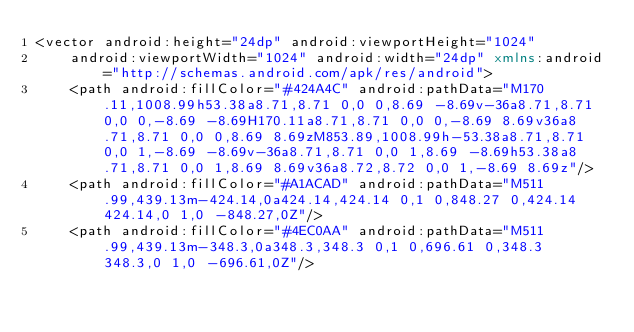Convert code to text. <code><loc_0><loc_0><loc_500><loc_500><_XML_><vector android:height="24dp" android:viewportHeight="1024"
    android:viewportWidth="1024" android:width="24dp" xmlns:android="http://schemas.android.com/apk/res/android">
    <path android:fillColor="#424A4C" android:pathData="M170.11,1008.99h53.38a8.71,8.71 0,0 0,8.69 -8.69v-36a8.71,8.71 0,0 0,-8.69 -8.69H170.11a8.71,8.71 0,0 0,-8.69 8.69v36a8.71,8.71 0,0 0,8.69 8.69zM853.89,1008.99h-53.38a8.71,8.71 0,0 1,-8.69 -8.69v-36a8.71,8.71 0,0 1,8.69 -8.69h53.38a8.71,8.71 0,0 1,8.69 8.69v36a8.72,8.72 0,0 1,-8.69 8.69z"/>
    <path android:fillColor="#A1ACAD" android:pathData="M511.99,439.13m-424.14,0a424.14,424.14 0,1 0,848.27 0,424.14 424.14,0 1,0 -848.27,0Z"/>
    <path android:fillColor="#4EC0AA" android:pathData="M511.99,439.13m-348.3,0a348.3,348.3 0,1 0,696.61 0,348.3 348.3,0 1,0 -696.61,0Z"/></code> 